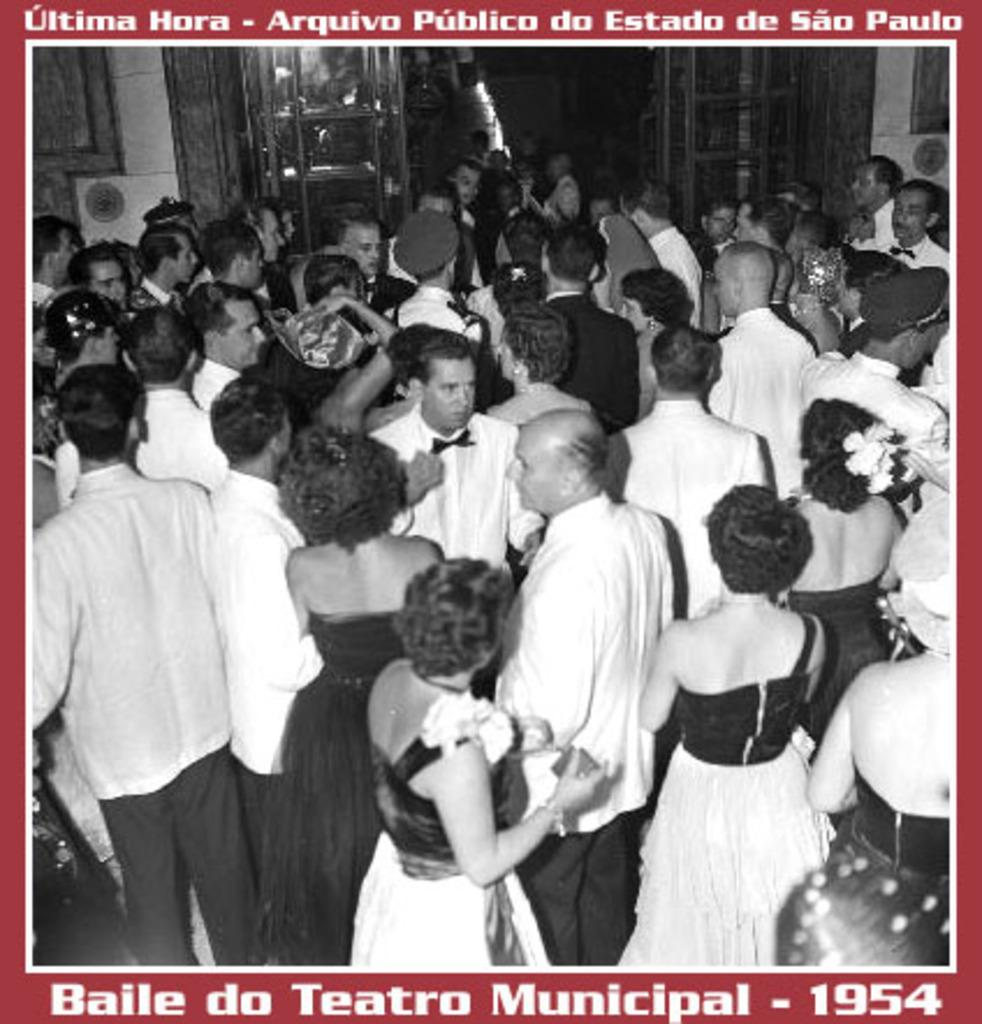What is happening in the image? There is a group of people standing in the image. What can be seen in the background of the image? There is a wall and a door in the background of the image. Is there any text visible in the image? Yes, there is text visible in the image. How many rabbits can be seen playing in the schoolyard in the image? There are no rabbits or schoolyard present in the image. 